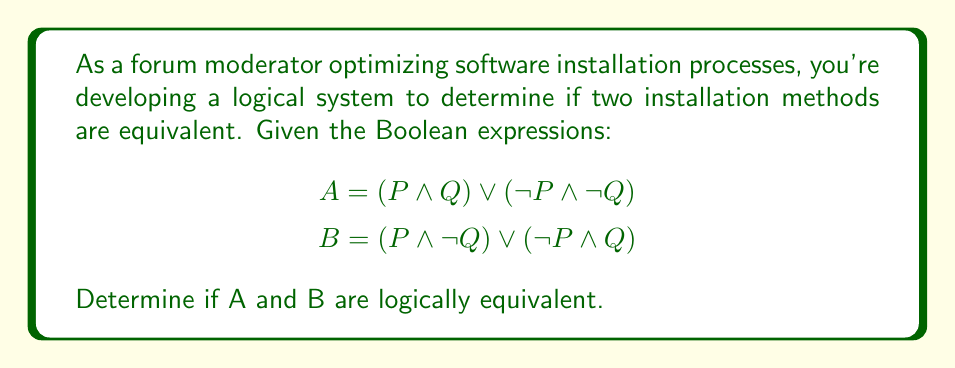What is the answer to this math problem? To determine if the two Boolean expressions are logically equivalent, we can use a truth table or simplify the expressions. Let's use a truth table approach:

1. Create a truth table with columns for P, Q, A, and B:

   | P | Q | A | B |
   |---|---|---|---|
   | 0 | 0 | 1 | 0 |
   | 0 | 1 | 0 | 1 |
   | 1 | 0 | 0 | 1 |
   | 1 | 1 | 1 | 0 |

2. Evaluate A for each row:
   - When P = 0 and Q = 0: $A = (0 \wedge 0) \vee (1 \wedge 1) = 0 \vee 1 = 1$
   - When P = 0 and Q = 1: $A = (0 \wedge 1) \vee (1 \wedge 0) = 0 \vee 0 = 0$
   - When P = 1 and Q = 0: $A = (1 \wedge 0) \vee (0 \wedge 1) = 0 \vee 0 = 0$
   - When P = 1 and Q = 1: $A = (1 \wedge 1) \vee (0 \wedge 0) = 1 \vee 0 = 1$

3. Evaluate B for each row:
   - When P = 0 and Q = 0: $B = (0 \wedge 1) \vee (1 \wedge 0) = 0 \vee 0 = 0$
   - When P = 0 and Q = 1: $B = (0 \wedge 0) \vee (1 \wedge 1) = 0 \vee 1 = 1$
   - When P = 1 and Q = 0: $B = (1 \wedge 1) \vee (0 \wedge 0) = 1 \vee 0 = 1$
   - When P = 1 and Q = 1: $B = (1 \wedge 0) \vee (0 \wedge 1) = 0 \vee 0 = 0$

4. Compare the results:
   We can see that A and B have different truth values for every combination of P and Q. This means they are not logically equivalent.

5. Interpretation in the context of software installation:
   If A represents one installation method and B represents another, the fact that they're not logically equivalent suggests that these methods will produce different outcomes under various conditions (represented by P and Q).
Answer: A and B are not logically equivalent. 